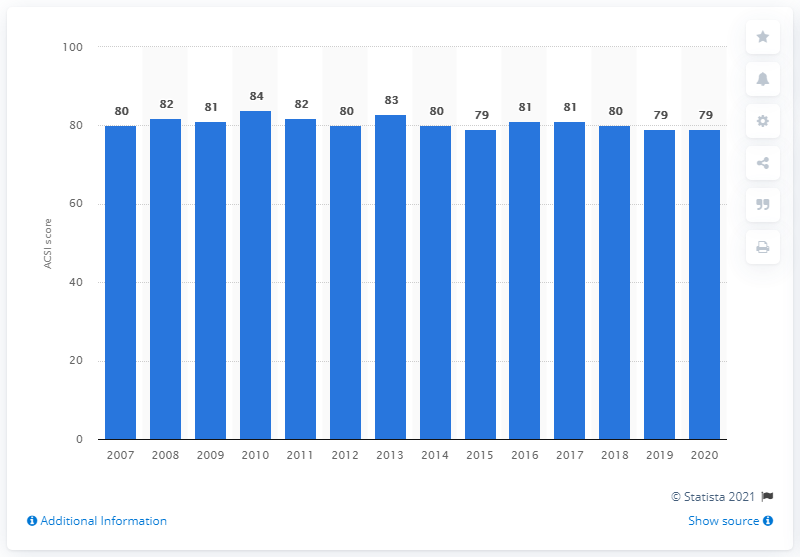Outline some significant characteristics in this image. In 2020, the ACSI score for Olive Garden restaurants in the U.S. was 79, indicating a generally positive customer experience. 